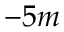<formula> <loc_0><loc_0><loc_500><loc_500>- 5 m</formula> 